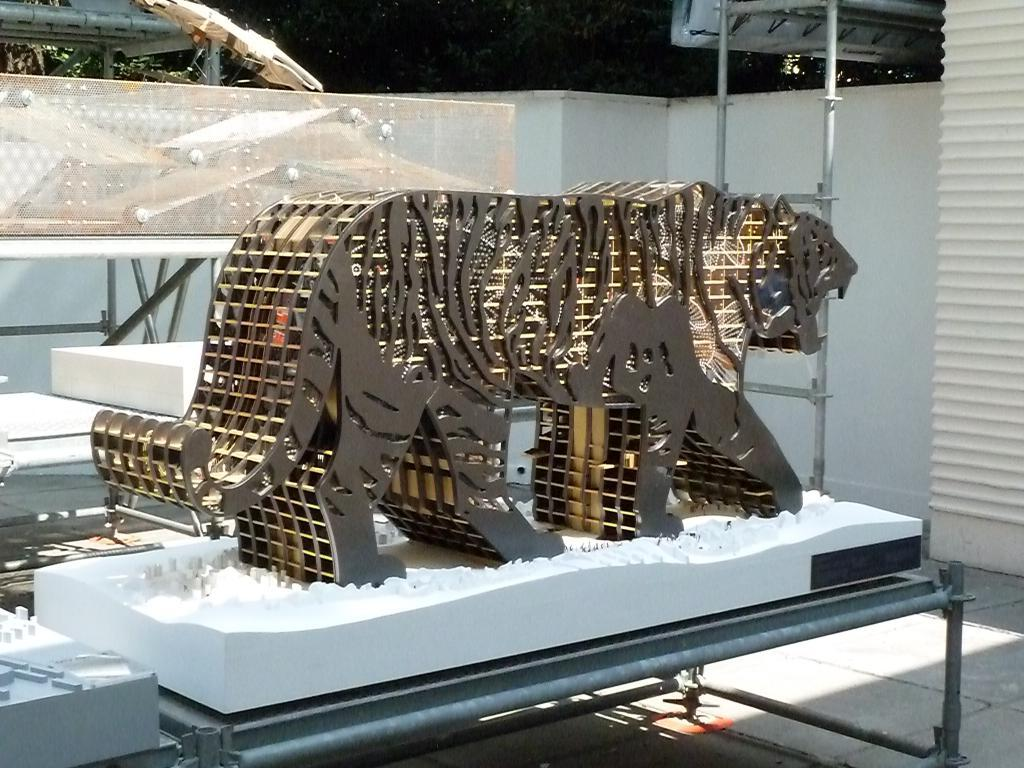What is the main subject of the image? There is a statue of a tiger in the image. Where is the statue located? The statue is on the floor. What can be seen in the background of the image? There is a wall and poles in the background of the image. Can you see a snail crawling on the statue in the image? There is no snail present on the statue in the image. Is there a frame around the statue in the image? The image does not show a frame around the statue. 